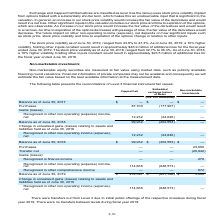According to Atlassian Plc's financial document, How are non-marketable equity securities measured? using market data, such as publicly available financing round valuations. The document states: "able equity securities are measured at fair value using market data, such as publicly available financing round valuations. Financial information of p..." Also, Why was there transfers out of Level 3 during fiscal year 2019? Due to initial public offerings of the respective investees. The document states: "There were transfers out from Level 3 due to initial public offerings of the respective investees during fiscal..." Also, What is the balance of capped call as of June 30, 2019? According to the financial document, $214,597 (in thousands). The relevant text states: "Balance as of June 30, 2019 $ 214,597 $ (851,126) $ 3,000..." Also, can you calculate: What is the change in the balance of capped call between fiscal year ended June 30, 2018 and 2019? Based on the calculation: 214,597-99,932, the result is 114665 (in thousands). This is based on the information: "Balance as of June 30, 2018 99,932 (202,553) — Balance as of June 30, 2019 $ 214,597 $ (851,126) $ 3,000..." The key data points involved are: 214,597, 99,932. Also, can you calculate: What is the percentage change in the balance of capped call between fiscal year ended June 30, 2018 and 2019? To answer this question, I need to perform calculations using the financial data. The calculation is: (214,597-99,932)/99,932, which equals 114.74 (percentage). This is based on the information: "Balance as of June 30, 2018 99,932 (202,553) — Balance as of June 30, 2019 $ 214,597 $ (851,126) $ 3,000..." The key data points involved are: 214,597, 99,932. Also, can you calculate: What is the difference in balance of capped call and non-marketable investments as of June 30, 2019? Based on the calculation: 214,597-3,000, the result is 211597 (in thousands). This is based on the information: "Purchases — — 23,000 Balance as of June 30, 2019 $ 214,597 $ (851,126) $ 3,000..." The key data points involved are: 214,597, 3,000. 